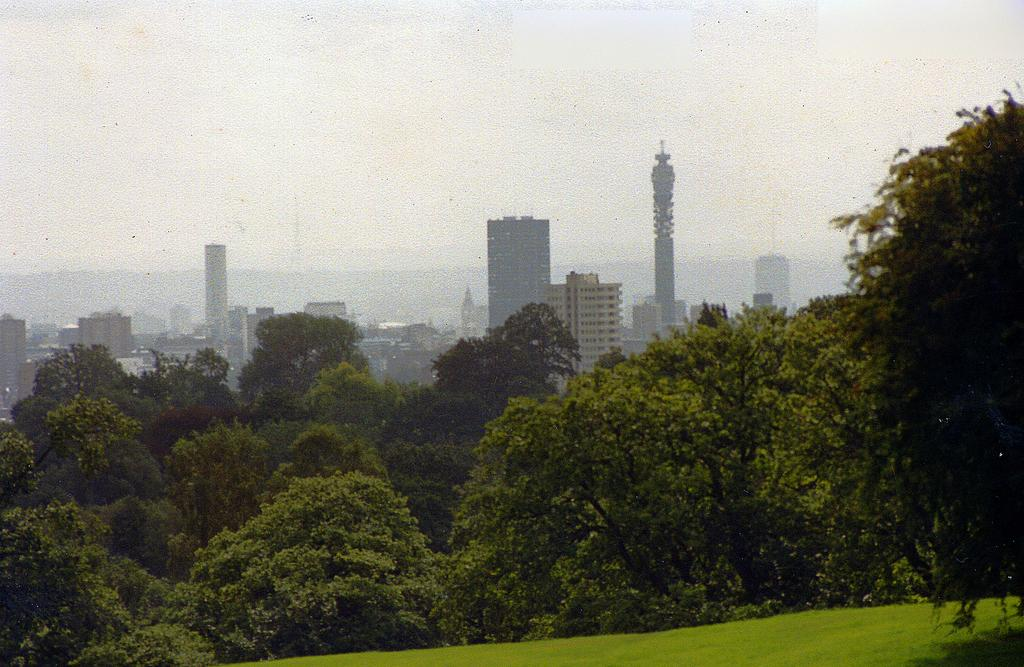What type of landscape is visible at the bottom of the image? There is grassland at the bottom side of the image. What can be seen in the center of the image? There are trees in the center of the image. What type of structures are visible in the background of the image? There are buildings in the background area of the image. What type of dogs can be seen forming a channel in the image? There are no dogs or channels present in the image. 